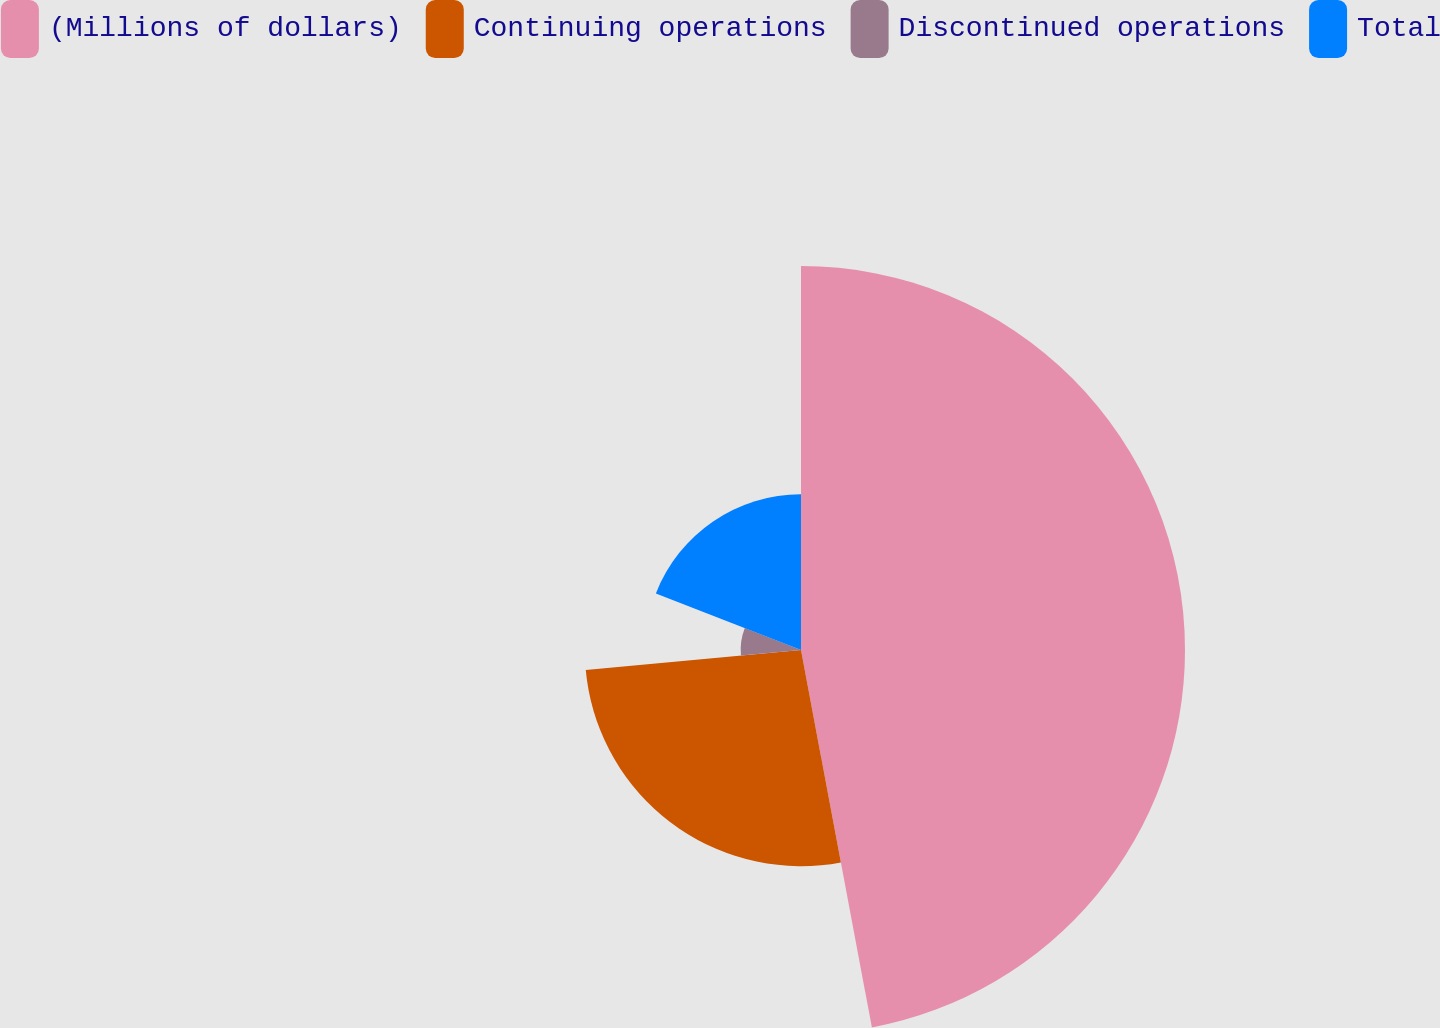Convert chart. <chart><loc_0><loc_0><loc_500><loc_500><pie_chart><fcel>(Millions of dollars)<fcel>Continuing operations<fcel>Discontinued operations<fcel>Total<nl><fcel>47.04%<fcel>26.48%<fcel>7.39%<fcel>19.08%<nl></chart> 